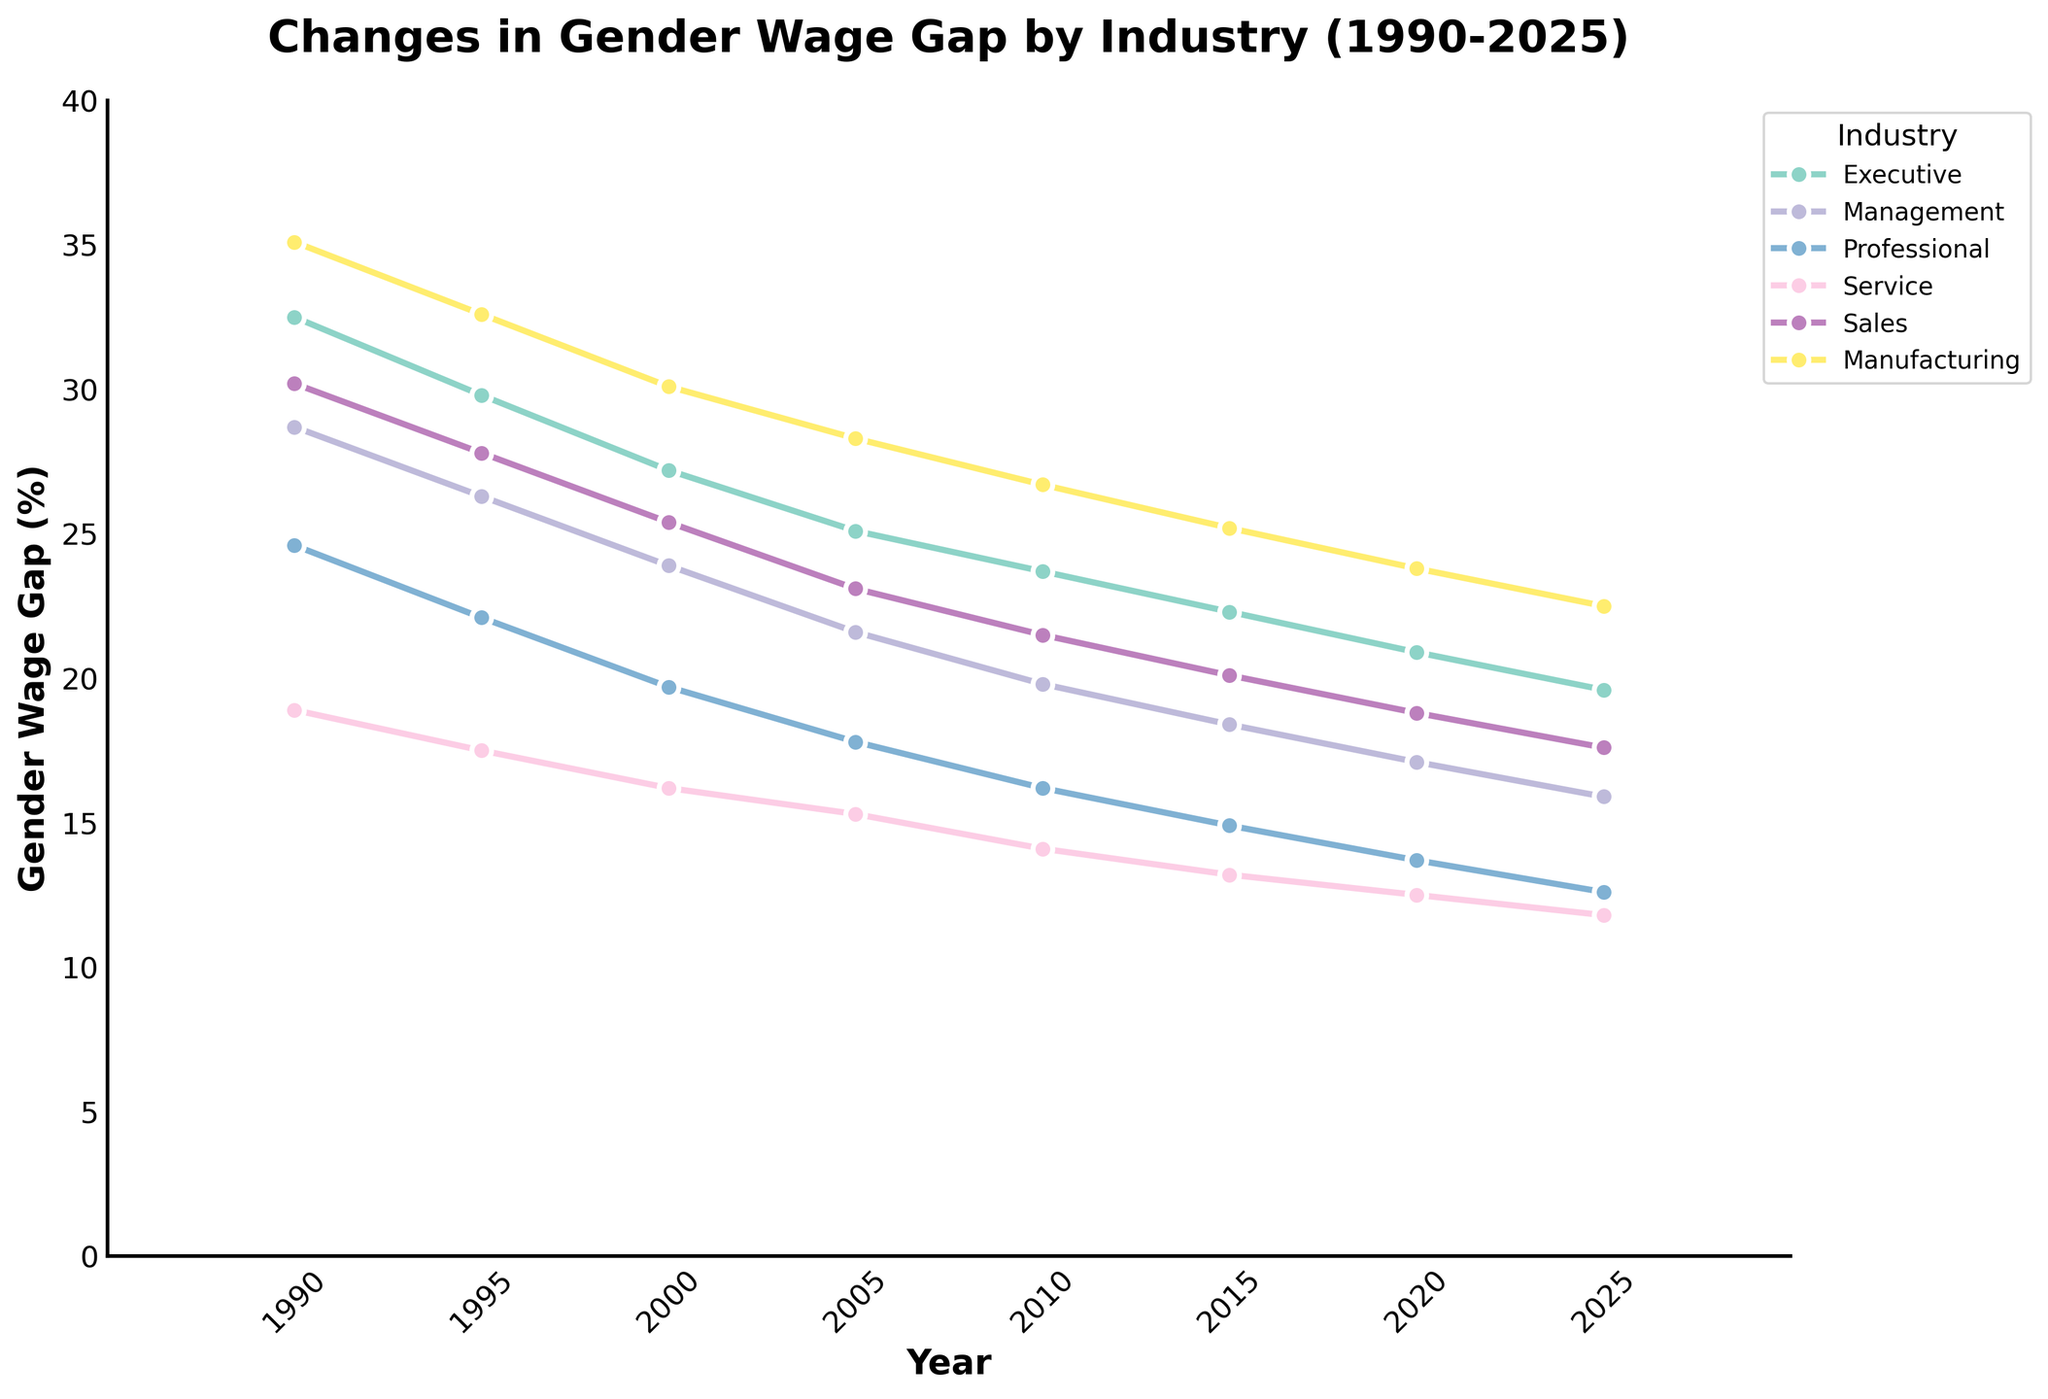How has the gender wage gap for executives changed from 1990 to 2000? To determine the change in the gender wage gap for executives from 1990 to 2000, we look at the values for those years: 32.5% in 1990 and 27.2% in 2000. The change is 32.5 - 27.2 = 5.3%
Answer: It decreased by 5.3% Which job level had the smallest gender wage gap in 2015? By examining the 2015 data, we see the wage gaps are: Executive 22.3%, Management 18.4%, Professional 14.9%, Service 13.2%, Sales 20.1%, Manufacturing 25.2%. The smallest wage gap is for Service at 13.2%
Answer: Service What is the average gender wage gap for manufacturing jobs over the years presented? To find the average, add up the wage gaps for manufacturing: 35.1 + 32.6 + 30.1 + 28.3 + 26.7 + 25.2 + 23.8 + 22.5 = 224.3. Then, divide by the number of years: 224.3 / 8 ≈ 28.04%
Answer: 28.04% Between 2000 and 2010, which job level showed the largest decrease in gender wage gap? Calculate the difference for each job level:
- Executive: 27.2 - 23.7 = 3.5%
- Management: 23.9 - 19.8 = 4.1%
- Professional: 19.7 - 16.2 = 3.5%
- Service: 16.2 - 14.1 = 2.1%
- Sales: 25.4 - 21.5 = 3.9%
- Manufacturing: 30.1 - 26.7 = 3.4%
The largest decrease is in Management at 4.1%
Answer: Management In which year did Management have a gender wage gap of approximately 20%? By examining the data points for Management, the closest to 20% is in 2010 with a gap of 19.8%
Answer: 2010 By how much did the gender wage gap for sales jobs decrease from 1990 to 2020? The decrease is found by subtracting the 2020 value from the 1990 value: 30.2 - 18.8 = 11.4%
Answer: 11.4% Which had a lower gender wage gap in 2005: Professional or Service jobs and by how much? In 2005, Professional's gap is 17.8% and Service's gap is 15.3%. Compute the difference: 17.8 - 15.3 = 2.5%. Hence, Service had a lower gap by 2.5%
Answer: Service by 2.5% Which industry had the steepest decline in gender wage gap from 1990 to 2025? For each industry, calculate the decline from 1990 to 2025:
- Executive: 32.5 - 19.6 = 12.9%
- Management: 28.7 - 15.9 = 12.8%
- Professional: 24.6 - 12.6 = 12.0%
- Service: 18.9 - 11.8 = 7.1%
- Sales: 30.2 - 17.6 = 12.6%
- Manufacturing: 35.1 - 22.5 = 12.6%
The steepest decline is in the Executive category by 12.9%
Answer: Executive What is the trend for the gender wage gap in professional jobs from 1990 to 2025? Observing the values over the years \(24.6 \rightarrow 12.6\), the trend is a consistent decrease
Answer: A consistent decrease 